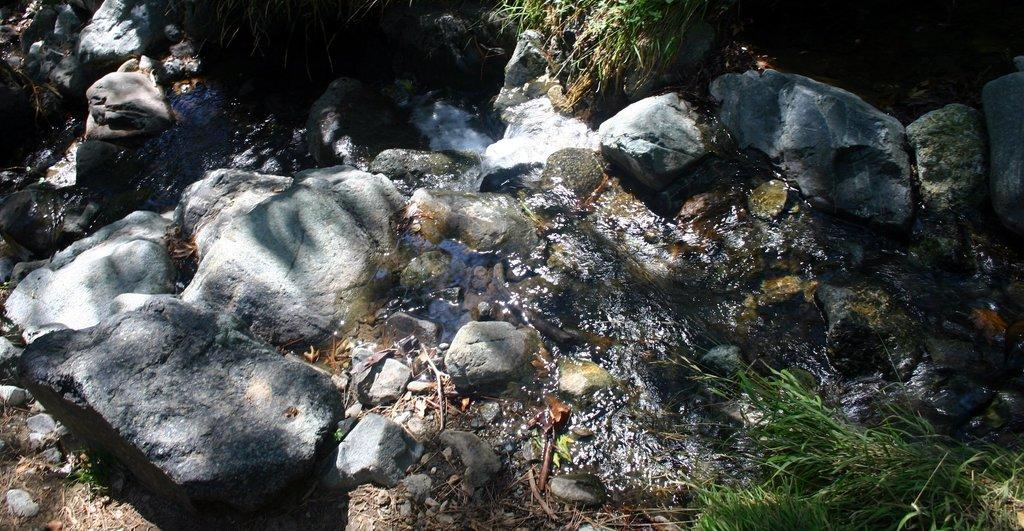Where was the image taken? The image was taken outdoors. What can be seen on the ground in the image? There are many rocks and stones on the ground, as well as grass. Is there any water visible in the image? Yes, there is water flowing on the ground in the image. How much grass is there in the image? The amount of grass cannot be determined from the image alone, as it only provides a snapshot of the scene. 